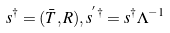<formula> <loc_0><loc_0><loc_500><loc_500>s ^ { \dag } = ( \bar { T } , R ) , s ^ { ^ { \prime } \dag } = s ^ { \dag } \Lambda ^ { - 1 }</formula> 